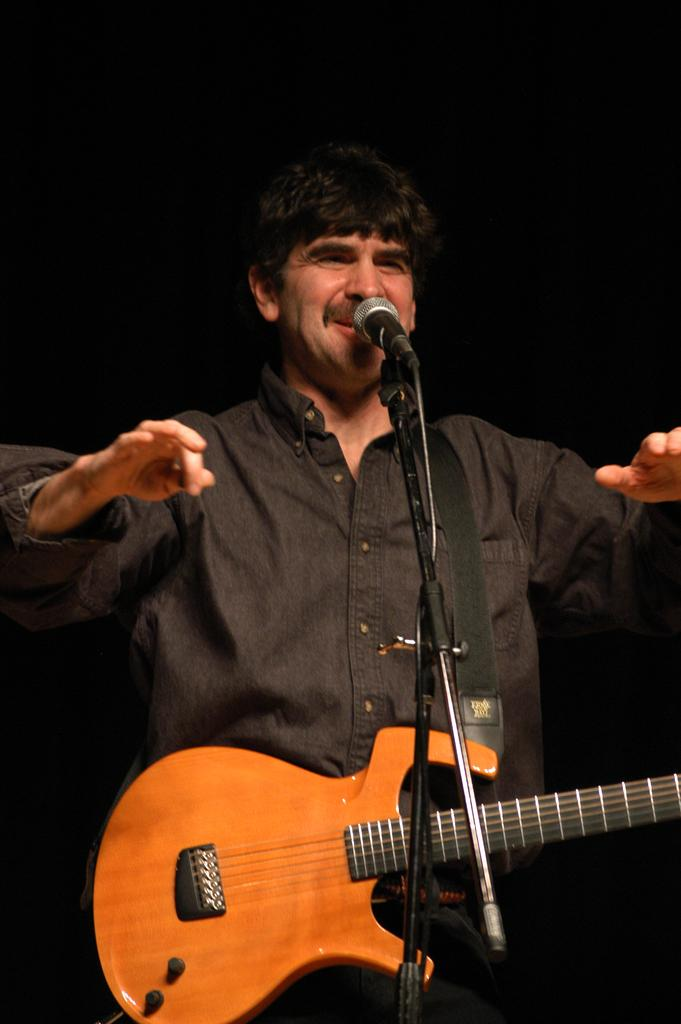What is the man in the image doing? The man is singing a song. What is the man wearing in the image? The man is wearing a black shirt. What is the man holding in the image? The man is holding a guitar. What is the man standing near in the image? There is a microphone and a microphone stand in the image. What scent can be detected from the man in the image? There is no information about the scent of the man in the image. What thought is the man having while singing in the image? There is no information about the man's thoughts while singing in the image. 